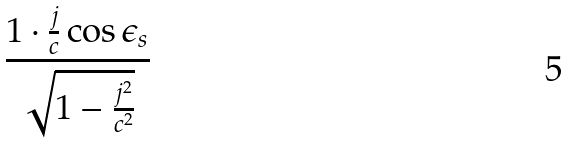<formula> <loc_0><loc_0><loc_500><loc_500>\frac { 1 \cdot \frac { j } { c } \cos \epsilon _ { s } } { \sqrt { 1 - \frac { j ^ { 2 } } { c ^ { 2 } } } }</formula> 